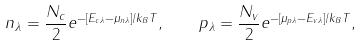Convert formula to latex. <formula><loc_0><loc_0><loc_500><loc_500>n _ { \lambda } = \frac { N _ { c } } { 2 } e ^ { - [ E _ { c \lambda } - \mu _ { n \lambda } ] / k _ { B } T } , \quad p _ { \lambda } = \frac { N _ { v } } { 2 } e ^ { - [ \mu _ { p \lambda } - E _ { v \lambda } ] / k _ { B } T } ,</formula> 